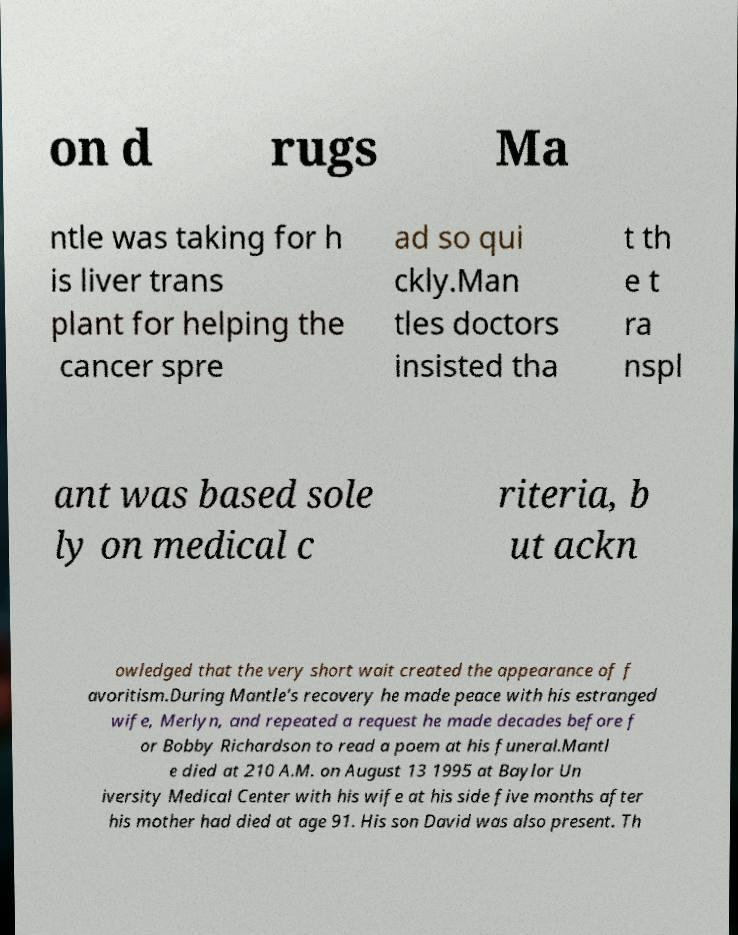Please identify and transcribe the text found in this image. on d rugs Ma ntle was taking for h is liver trans plant for helping the cancer spre ad so qui ckly.Man tles doctors insisted tha t th e t ra nspl ant was based sole ly on medical c riteria, b ut ackn owledged that the very short wait created the appearance of f avoritism.During Mantle's recovery he made peace with his estranged wife, Merlyn, and repeated a request he made decades before f or Bobby Richardson to read a poem at his funeral.Mantl e died at 210 A.M. on August 13 1995 at Baylor Un iversity Medical Center with his wife at his side five months after his mother had died at age 91. His son David was also present. Th 